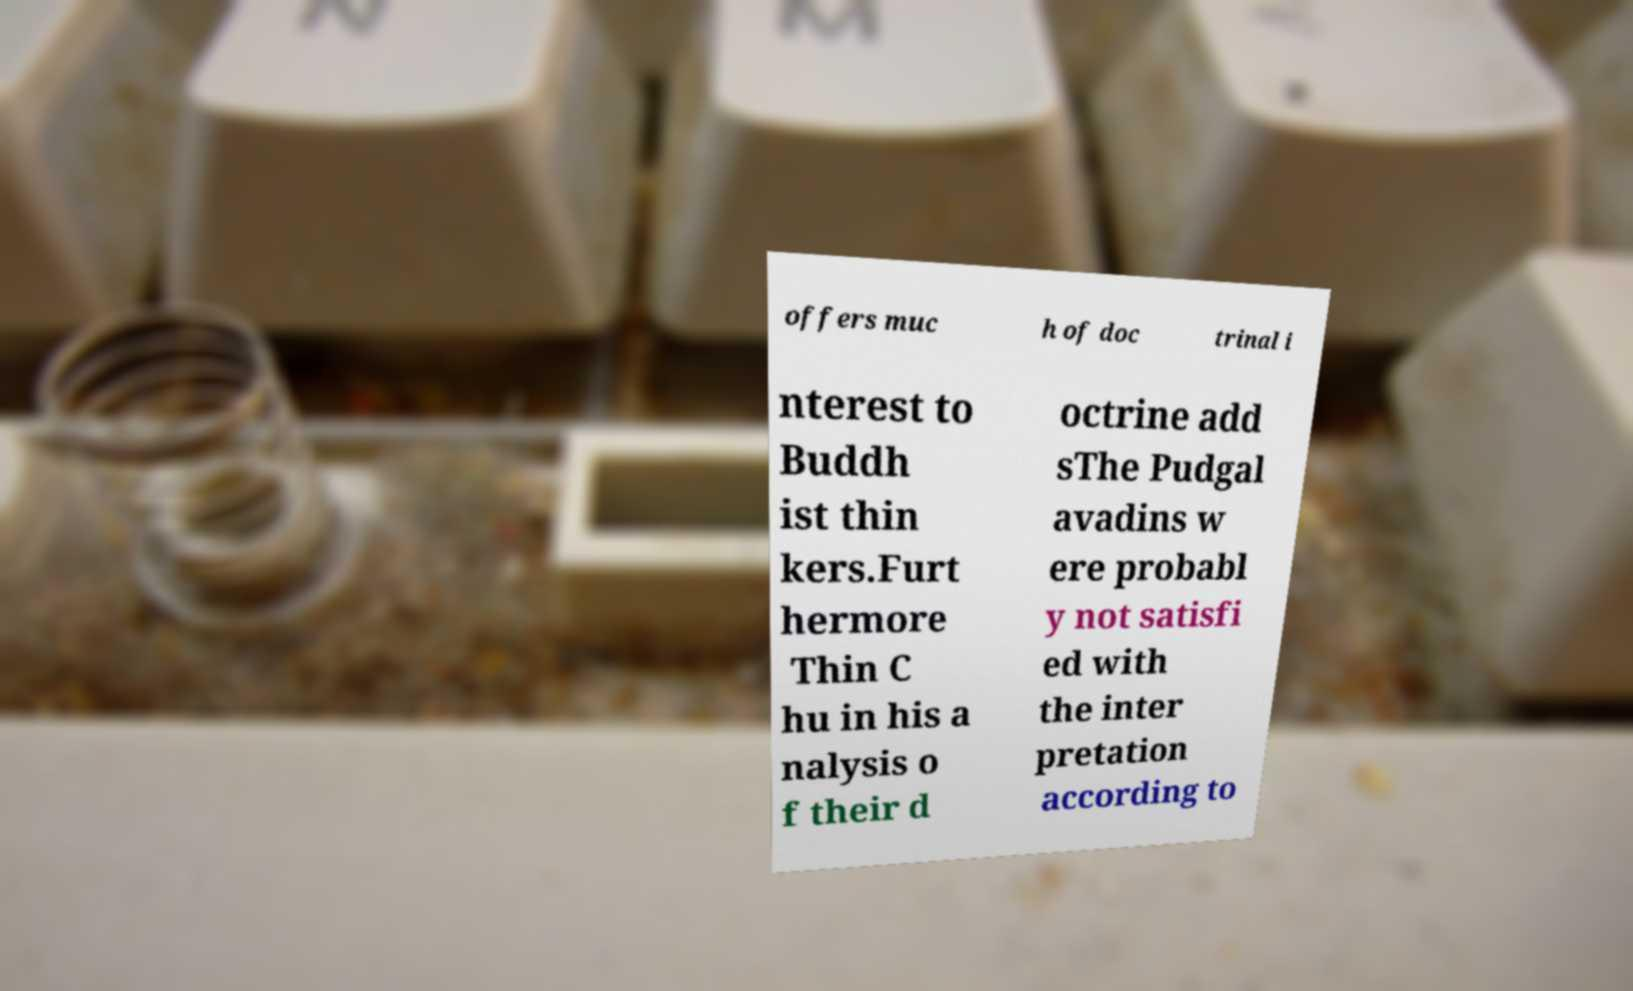Please read and relay the text visible in this image. What does it say? offers muc h of doc trinal i nterest to Buddh ist thin kers.Furt hermore Thin C hu in his a nalysis o f their d octrine add sThe Pudgal avadins w ere probabl y not satisfi ed with the inter pretation according to 